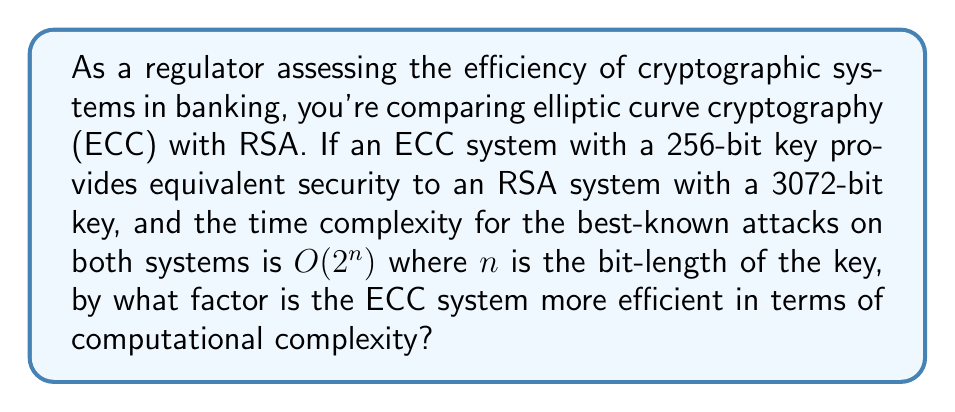Can you answer this question? To solve this problem, we need to follow these steps:

1) First, let's identify the key sizes:
   ECC: 256-bit key
   RSA: 3072-bit key

2) The time complexity for both systems is given as $O(2^n)$, where $n$ is the bit-length of the key.

3) For ECC:
   Time complexity = $O(2^{256})$

4) For RSA:
   Time complexity = $O(2^{3072})$

5) To compare the efficiency, we need to find the ratio of these complexities:

   $$\frac{\text{RSA complexity}}{\text{ECC complexity}} = \frac{O(2^{3072})}{O(2^{256})}$$

6) Using the properties of exponentials, we can simplify this:

   $$\frac{O(2^{3072})}{O(2^{256})} = O(2^{3072-256}) = O(2^{2816})$$

7) This means that the RSA system is approximately $2^{2816}$ times more computationally complex than the ECC system.

8) To express this as a factor by which ECC is more efficient, we take the reciprocal:

   ECC efficiency factor = $\frac{1}{2^{2816}}$

This immense factor demonstrates the significant efficiency advantage of ECC over RSA for equivalent security levels, which is crucial for resource-constrained environments in the banking sector.
Answer: $\frac{1}{2^{2816}}$ 